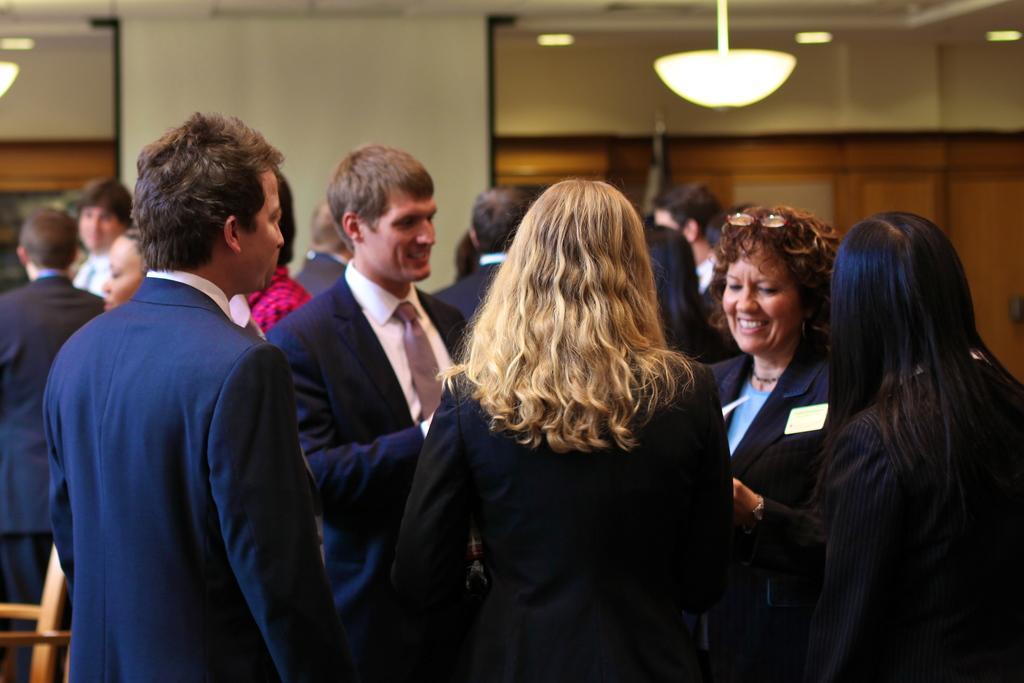Could you give a brief overview of what you see in this image? There are people in the foreground area of the image, it seems like doors, people and lamps in the background. 